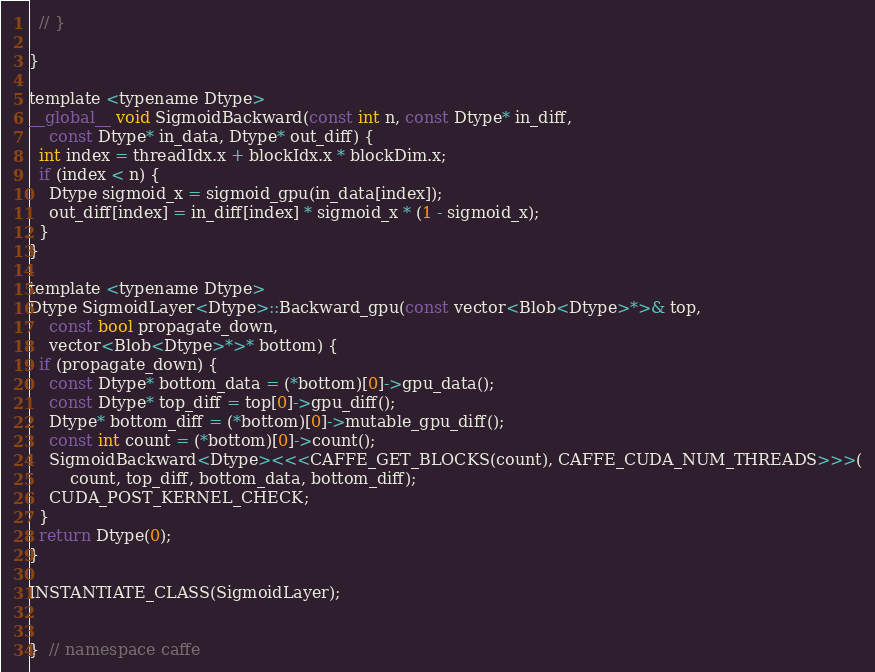Convert code to text. <code><loc_0><loc_0><loc_500><loc_500><_Cuda_>  // }
  
}

template <typename Dtype>
__global__ void SigmoidBackward(const int n, const Dtype* in_diff,
    const Dtype* in_data, Dtype* out_diff) {
  int index = threadIdx.x + blockIdx.x * blockDim.x;
  if (index < n) {
    Dtype sigmoid_x = sigmoid_gpu(in_data[index]);
    out_diff[index] = in_diff[index] * sigmoid_x * (1 - sigmoid_x);
  }
}

template <typename Dtype>
Dtype SigmoidLayer<Dtype>::Backward_gpu(const vector<Blob<Dtype>*>& top,
    const bool propagate_down,
    vector<Blob<Dtype>*>* bottom) {
  if (propagate_down) {
    const Dtype* bottom_data = (*bottom)[0]->gpu_data();
    const Dtype* top_diff = top[0]->gpu_diff();
    Dtype* bottom_diff = (*bottom)[0]->mutable_gpu_diff();
    const int count = (*bottom)[0]->count();
    SigmoidBackward<Dtype><<<CAFFE_GET_BLOCKS(count), CAFFE_CUDA_NUM_THREADS>>>(
        count, top_diff, bottom_data, bottom_diff);
    CUDA_POST_KERNEL_CHECK;
  }
  return Dtype(0);
}

INSTANTIATE_CLASS(SigmoidLayer);


}  // namespace caffe
</code> 